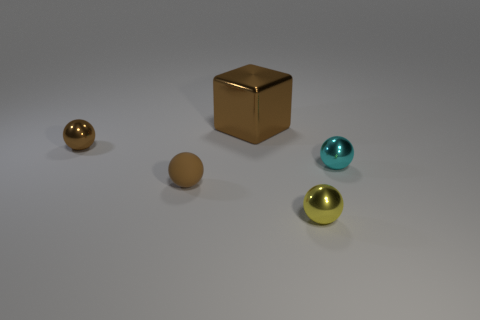Do the tiny cyan thing and the yellow shiny thing have the same shape?
Your response must be concise. Yes. How many large things are either cyan shiny spheres or brown matte cubes?
Make the answer very short. 0. There is a large thing that is the same material as the yellow sphere; what color is it?
Make the answer very short. Brown. What number of small yellow balls have the same material as the block?
Offer a terse response. 1. There is a thing to the left of the rubber thing; is its size the same as the brown rubber object behind the tiny yellow shiny ball?
Provide a short and direct response. Yes. There is a small ball that is in front of the small brown rubber thing to the left of the cyan metal thing; what is it made of?
Your response must be concise. Metal. Are there fewer shiny balls in front of the small rubber sphere than rubber objects that are behind the big brown object?
Provide a succinct answer. No. There is a big thing that is the same color as the small rubber sphere; what is its material?
Keep it short and to the point. Metal. Is there any other thing that has the same shape as the large brown thing?
Your answer should be compact. No. There is a tiny ball on the right side of the yellow thing; what is it made of?
Offer a very short reply. Metal. 